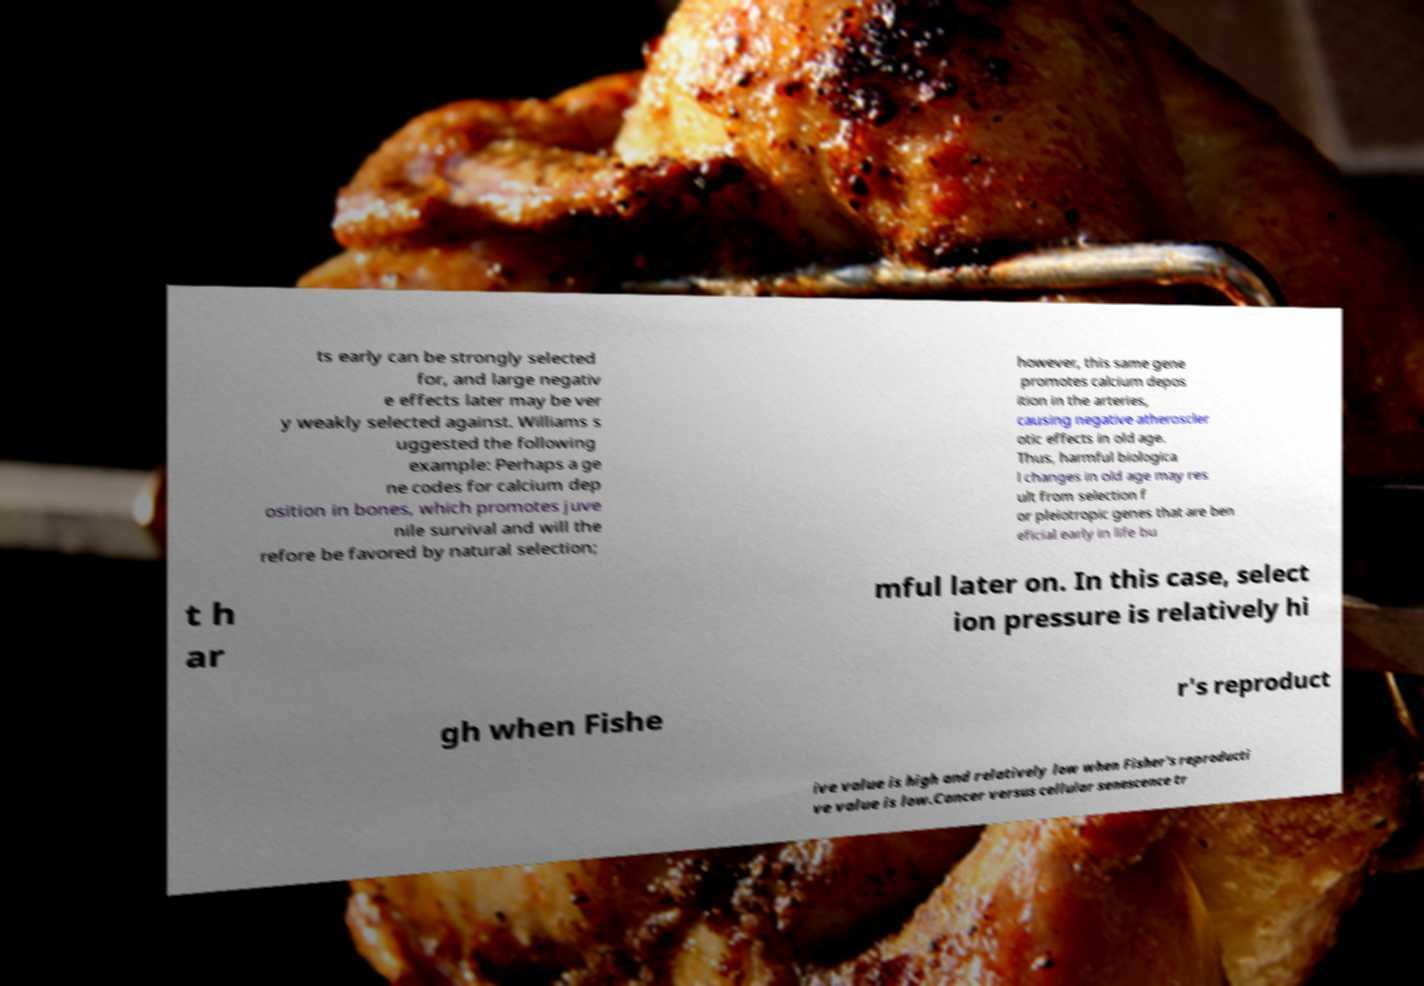There's text embedded in this image that I need extracted. Can you transcribe it verbatim? ts early can be strongly selected for, and large negativ e effects later may be ver y weakly selected against. Williams s uggested the following example: Perhaps a ge ne codes for calcium dep osition in bones, which promotes juve nile survival and will the refore be favored by natural selection; however, this same gene promotes calcium depos ition in the arteries, causing negative atheroscler otic effects in old age. Thus, harmful biologica l changes in old age may res ult from selection f or pleiotropic genes that are ben eficial early in life bu t h ar mful later on. In this case, select ion pressure is relatively hi gh when Fishe r's reproduct ive value is high and relatively low when Fisher's reproducti ve value is low.Cancer versus cellular senescence tr 